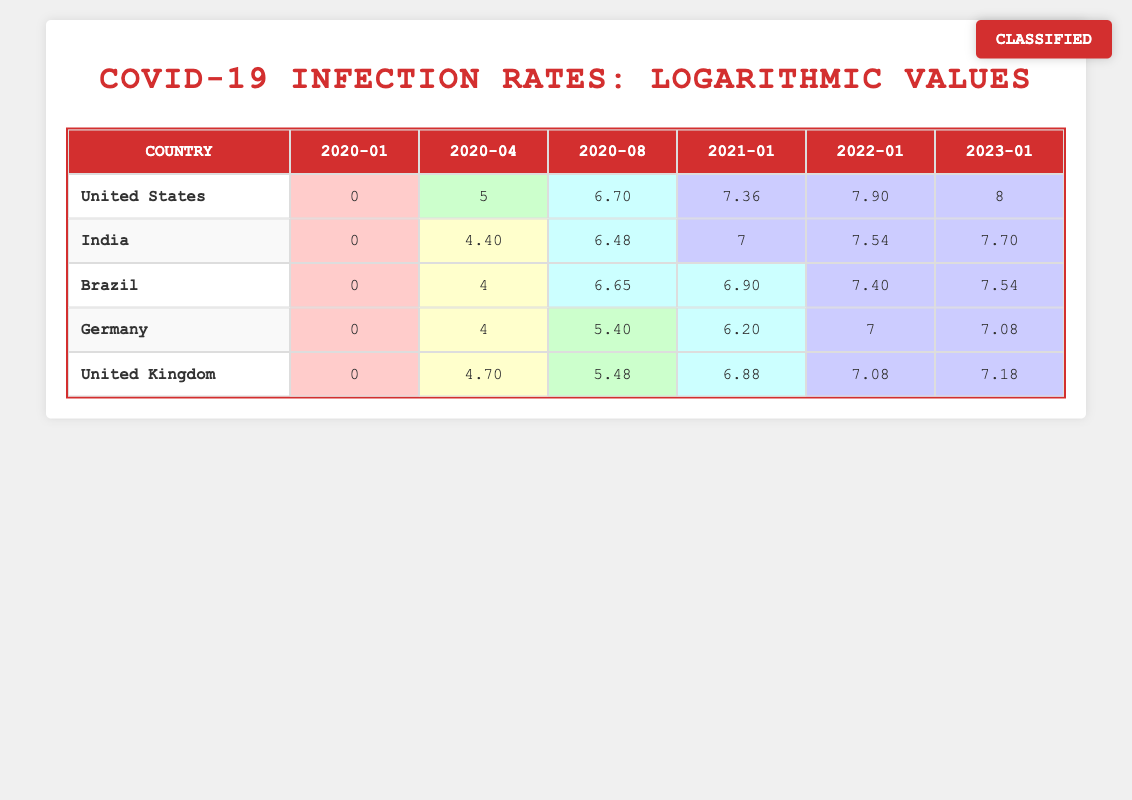what is the COVID-19 infection rate in the United States for January 2021? The table shows the value under the "2021-01" column corresponding to the "United States" row, which is 7.36.
Answer: 7.36 which country had the second highest COVID-19 infection rate in January 2023? In January 2023, the United States had 8, India had 7.70, Brazil had 7.54, Germany had 7.08, and the United Kingdom had 7.18. Sorting these values, India is the second highest.
Answer: India what is the average infection rate for Germany across all recorded dates? The infection rates for Germany are: 0 (2020-01), 4 (2020-04), 5.40 (2020-08), 6.20 (2021-01), 7 (2022-01), 7.08 (2023-01). Adding these values (0 + 4 + 5.40 + 6.20 + 7 + 7.08) gives 29.68. Divide this by 6 to find the average: 29.68 / 6 = 4.95.
Answer: 4.95 is it true that Brazil had higher infection rates than Germany in every time period listed? Comparing the values for Brazil and Germany: Brazil's values are 0, 4, 6.65, 6.90, 7.40, and 7.54. Germany's values are 0, 4, 5.40, 6.20, 7, and 7.08. In April 2020, values are equal (4), but in all other periods, Brazil had higher values. Therefore, it is not true as they were equal in one instance.
Answer: No which country experienced the most rapid increase in COVID-19 infection rates between April 2020 and January 2021? For April 2020, the rates were: United States (5), India (4.40), Brazil (4), Germany (4), United Kingdom (4.70). For January 2021, the rates were: United States (7.36), India (7), Brazil (6.90), Germany (6.20), United Kingdom (6.88). Calculating the differences shows the United States had the highest increase (7.36 - 5 = 2.36).
Answer: United States 